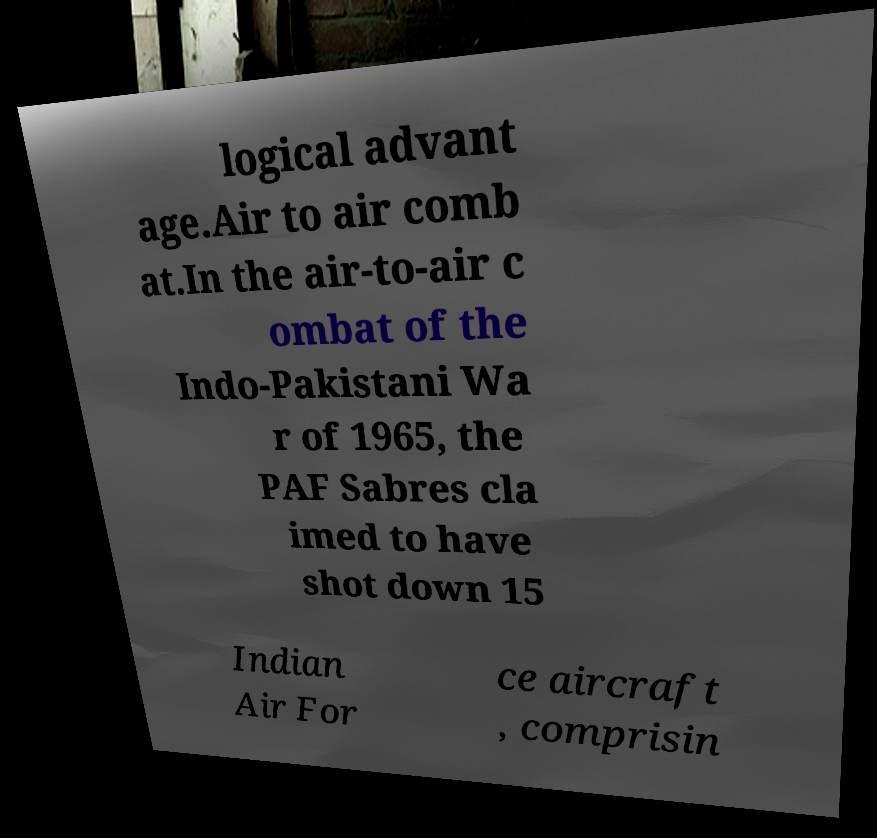There's text embedded in this image that I need extracted. Can you transcribe it verbatim? logical advant age.Air to air comb at.In the air-to-air c ombat of the Indo-Pakistani Wa r of 1965, the PAF Sabres cla imed to have shot down 15 Indian Air For ce aircraft , comprisin 